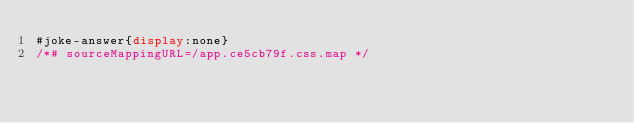Convert code to text. <code><loc_0><loc_0><loc_500><loc_500><_CSS_>#joke-answer{display:none}
/*# sourceMappingURL=/app.ce5cb79f.css.map */</code> 